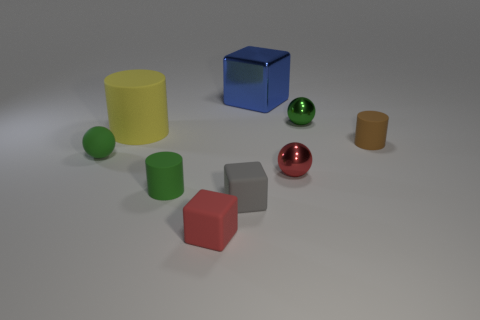Subtract all large purple cylinders. Subtract all big shiny things. How many objects are left? 8 Add 9 green matte cylinders. How many green matte cylinders are left? 10 Add 3 metal spheres. How many metal spheres exist? 5 Subtract 1 red cubes. How many objects are left? 8 